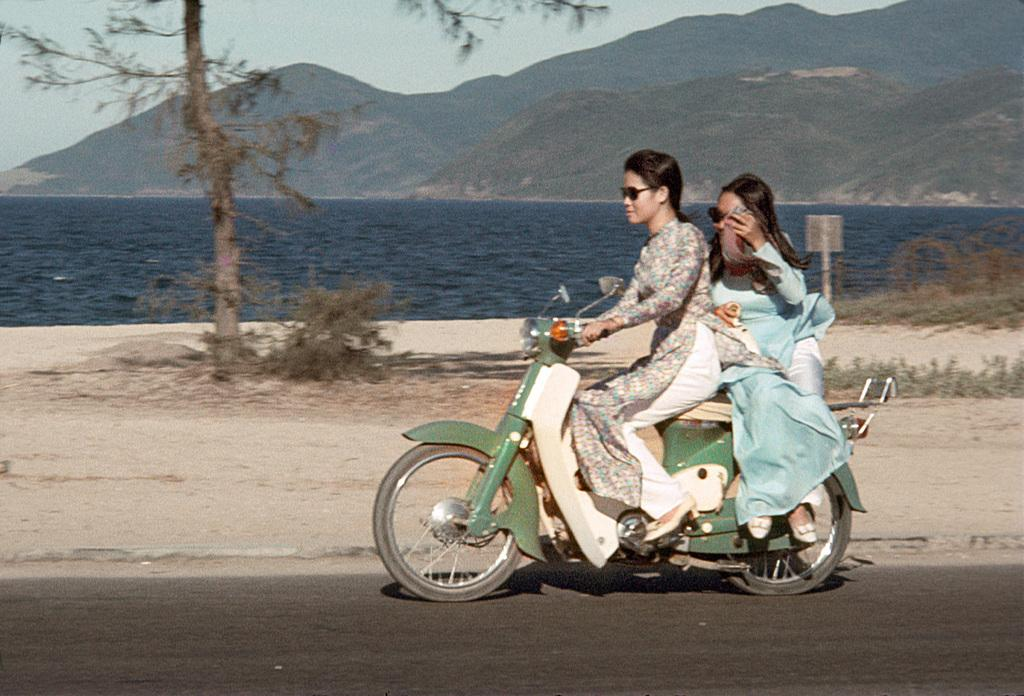How many women are in the image? There are two women in the image. What are the women doing in the image? The women are riding a Scooty. What type of vegetation can be seen in the image? There are trees and plants visible in the image. What natural feature can be seen in the image? There is water and hills visible in the image. Where is the shelf located in the image? There is no shelf present in the image. Can you see an airplane in the image? There is no airplane visible in the image. 